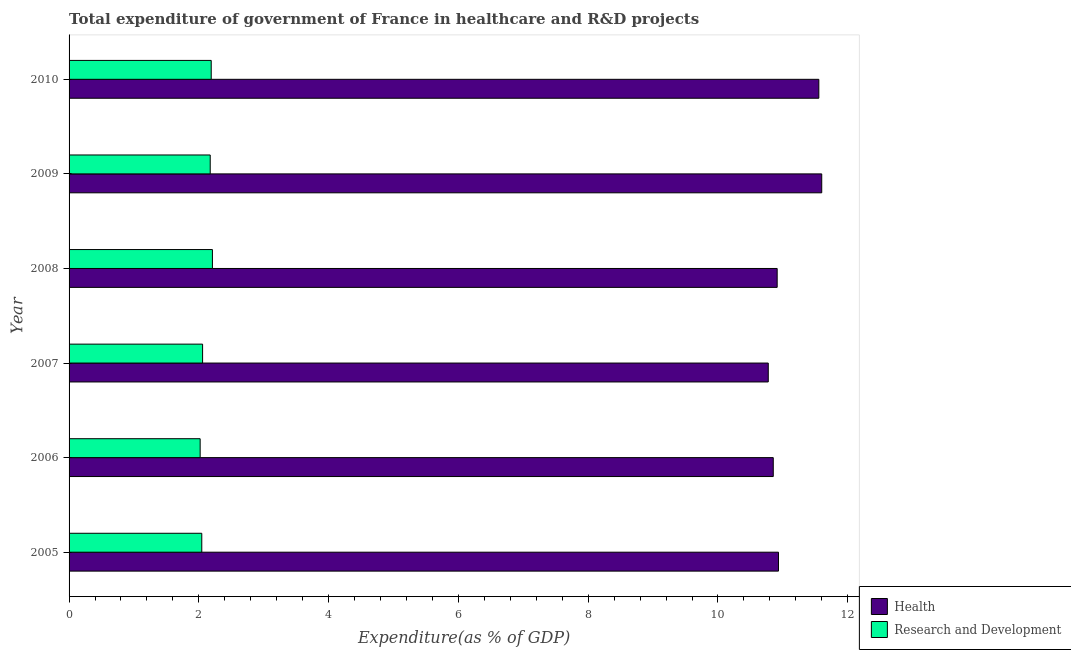How many different coloured bars are there?
Give a very brief answer. 2. What is the label of the 2nd group of bars from the top?
Offer a very short reply. 2009. In how many cases, is the number of bars for a given year not equal to the number of legend labels?
Offer a terse response. 0. What is the expenditure in healthcare in 2005?
Provide a succinct answer. 10.93. Across all years, what is the maximum expenditure in r&d?
Ensure brevity in your answer.  2.21. Across all years, what is the minimum expenditure in r&d?
Offer a terse response. 2.02. What is the total expenditure in healthcare in the graph?
Make the answer very short. 66.63. What is the difference between the expenditure in r&d in 2006 and that in 2009?
Provide a succinct answer. -0.15. What is the difference between the expenditure in healthcare in 2005 and the expenditure in r&d in 2010?
Offer a very short reply. 8.74. What is the average expenditure in healthcare per year?
Keep it short and to the point. 11.1. In the year 2006, what is the difference between the expenditure in r&d and expenditure in healthcare?
Your answer should be compact. -8.83. In how many years, is the expenditure in r&d greater than 4.8 %?
Ensure brevity in your answer.  0. What is the ratio of the expenditure in healthcare in 2005 to that in 2010?
Your answer should be very brief. 0.95. Is the expenditure in healthcare in 2006 less than that in 2007?
Provide a succinct answer. No. What is the difference between the highest and the second highest expenditure in r&d?
Give a very brief answer. 0.02. What is the difference between the highest and the lowest expenditure in healthcare?
Provide a succinct answer. 0.82. Is the sum of the expenditure in healthcare in 2005 and 2009 greater than the maximum expenditure in r&d across all years?
Provide a succinct answer. Yes. What does the 2nd bar from the top in 2006 represents?
Your answer should be very brief. Health. What does the 2nd bar from the bottom in 2010 represents?
Make the answer very short. Research and Development. How many bars are there?
Make the answer very short. 12. What is the difference between two consecutive major ticks on the X-axis?
Offer a very short reply. 2. Are the values on the major ticks of X-axis written in scientific E-notation?
Your answer should be very brief. No. Does the graph contain grids?
Provide a short and direct response. No. Where does the legend appear in the graph?
Provide a succinct answer. Bottom right. How are the legend labels stacked?
Your response must be concise. Vertical. What is the title of the graph?
Offer a terse response. Total expenditure of government of France in healthcare and R&D projects. Does "Arms imports" appear as one of the legend labels in the graph?
Ensure brevity in your answer.  No. What is the label or title of the X-axis?
Your response must be concise. Expenditure(as % of GDP). What is the label or title of the Y-axis?
Give a very brief answer. Year. What is the Expenditure(as % of GDP) in Health in 2005?
Make the answer very short. 10.93. What is the Expenditure(as % of GDP) of Research and Development in 2005?
Provide a short and direct response. 2.05. What is the Expenditure(as % of GDP) in Health in 2006?
Offer a terse response. 10.85. What is the Expenditure(as % of GDP) in Research and Development in 2006?
Make the answer very short. 2.02. What is the Expenditure(as % of GDP) in Health in 2007?
Your answer should be compact. 10.78. What is the Expenditure(as % of GDP) in Research and Development in 2007?
Provide a short and direct response. 2.06. What is the Expenditure(as % of GDP) of Health in 2008?
Provide a succinct answer. 10.91. What is the Expenditure(as % of GDP) in Research and Development in 2008?
Make the answer very short. 2.21. What is the Expenditure(as % of GDP) in Health in 2009?
Ensure brevity in your answer.  11.6. What is the Expenditure(as % of GDP) in Research and Development in 2009?
Keep it short and to the point. 2.18. What is the Expenditure(as % of GDP) of Health in 2010?
Ensure brevity in your answer.  11.55. What is the Expenditure(as % of GDP) in Research and Development in 2010?
Provide a succinct answer. 2.19. Across all years, what is the maximum Expenditure(as % of GDP) of Health?
Offer a very short reply. 11.6. Across all years, what is the maximum Expenditure(as % of GDP) of Research and Development?
Provide a short and direct response. 2.21. Across all years, what is the minimum Expenditure(as % of GDP) in Health?
Keep it short and to the point. 10.78. Across all years, what is the minimum Expenditure(as % of GDP) in Research and Development?
Ensure brevity in your answer.  2.02. What is the total Expenditure(as % of GDP) of Health in the graph?
Offer a terse response. 66.63. What is the total Expenditure(as % of GDP) in Research and Development in the graph?
Make the answer very short. 12.7. What is the difference between the Expenditure(as % of GDP) of Health in 2005 and that in 2006?
Your answer should be very brief. 0.08. What is the difference between the Expenditure(as % of GDP) of Research and Development in 2005 and that in 2006?
Offer a terse response. 0.03. What is the difference between the Expenditure(as % of GDP) of Health in 2005 and that in 2007?
Your answer should be compact. 0.16. What is the difference between the Expenditure(as % of GDP) in Research and Development in 2005 and that in 2007?
Keep it short and to the point. -0.01. What is the difference between the Expenditure(as % of GDP) in Health in 2005 and that in 2008?
Ensure brevity in your answer.  0.02. What is the difference between the Expenditure(as % of GDP) in Research and Development in 2005 and that in 2008?
Make the answer very short. -0.16. What is the difference between the Expenditure(as % of GDP) in Health in 2005 and that in 2009?
Keep it short and to the point. -0.67. What is the difference between the Expenditure(as % of GDP) in Research and Development in 2005 and that in 2009?
Offer a terse response. -0.13. What is the difference between the Expenditure(as % of GDP) of Health in 2005 and that in 2010?
Make the answer very short. -0.62. What is the difference between the Expenditure(as % of GDP) in Research and Development in 2005 and that in 2010?
Offer a terse response. -0.15. What is the difference between the Expenditure(as % of GDP) in Health in 2006 and that in 2007?
Give a very brief answer. 0.08. What is the difference between the Expenditure(as % of GDP) in Research and Development in 2006 and that in 2007?
Provide a succinct answer. -0.04. What is the difference between the Expenditure(as % of GDP) of Health in 2006 and that in 2008?
Give a very brief answer. -0.06. What is the difference between the Expenditure(as % of GDP) of Research and Development in 2006 and that in 2008?
Offer a terse response. -0.19. What is the difference between the Expenditure(as % of GDP) in Health in 2006 and that in 2009?
Your answer should be compact. -0.75. What is the difference between the Expenditure(as % of GDP) of Research and Development in 2006 and that in 2009?
Your answer should be compact. -0.16. What is the difference between the Expenditure(as % of GDP) in Health in 2006 and that in 2010?
Provide a succinct answer. -0.7. What is the difference between the Expenditure(as % of GDP) of Research and Development in 2006 and that in 2010?
Offer a very short reply. -0.17. What is the difference between the Expenditure(as % of GDP) of Health in 2007 and that in 2008?
Provide a succinct answer. -0.14. What is the difference between the Expenditure(as % of GDP) of Research and Development in 2007 and that in 2008?
Offer a terse response. -0.15. What is the difference between the Expenditure(as % of GDP) of Health in 2007 and that in 2009?
Make the answer very short. -0.82. What is the difference between the Expenditure(as % of GDP) of Research and Development in 2007 and that in 2009?
Your answer should be very brief. -0.12. What is the difference between the Expenditure(as % of GDP) of Health in 2007 and that in 2010?
Offer a terse response. -0.78. What is the difference between the Expenditure(as % of GDP) of Research and Development in 2007 and that in 2010?
Provide a succinct answer. -0.13. What is the difference between the Expenditure(as % of GDP) of Health in 2008 and that in 2009?
Your answer should be compact. -0.69. What is the difference between the Expenditure(as % of GDP) in Research and Development in 2008 and that in 2009?
Offer a terse response. 0.03. What is the difference between the Expenditure(as % of GDP) in Health in 2008 and that in 2010?
Ensure brevity in your answer.  -0.64. What is the difference between the Expenditure(as % of GDP) in Research and Development in 2008 and that in 2010?
Your answer should be very brief. 0.02. What is the difference between the Expenditure(as % of GDP) in Health in 2009 and that in 2010?
Provide a succinct answer. 0.04. What is the difference between the Expenditure(as % of GDP) of Research and Development in 2009 and that in 2010?
Keep it short and to the point. -0.02. What is the difference between the Expenditure(as % of GDP) in Health in 2005 and the Expenditure(as % of GDP) in Research and Development in 2006?
Give a very brief answer. 8.91. What is the difference between the Expenditure(as % of GDP) of Health in 2005 and the Expenditure(as % of GDP) of Research and Development in 2007?
Provide a short and direct response. 8.88. What is the difference between the Expenditure(as % of GDP) in Health in 2005 and the Expenditure(as % of GDP) in Research and Development in 2008?
Give a very brief answer. 8.72. What is the difference between the Expenditure(as % of GDP) in Health in 2005 and the Expenditure(as % of GDP) in Research and Development in 2009?
Make the answer very short. 8.76. What is the difference between the Expenditure(as % of GDP) in Health in 2005 and the Expenditure(as % of GDP) in Research and Development in 2010?
Your answer should be very brief. 8.74. What is the difference between the Expenditure(as % of GDP) in Health in 2006 and the Expenditure(as % of GDP) in Research and Development in 2007?
Your response must be concise. 8.79. What is the difference between the Expenditure(as % of GDP) in Health in 2006 and the Expenditure(as % of GDP) in Research and Development in 2008?
Make the answer very short. 8.64. What is the difference between the Expenditure(as % of GDP) in Health in 2006 and the Expenditure(as % of GDP) in Research and Development in 2009?
Offer a very short reply. 8.68. What is the difference between the Expenditure(as % of GDP) in Health in 2006 and the Expenditure(as % of GDP) in Research and Development in 2010?
Your answer should be compact. 8.66. What is the difference between the Expenditure(as % of GDP) of Health in 2007 and the Expenditure(as % of GDP) of Research and Development in 2008?
Offer a terse response. 8.57. What is the difference between the Expenditure(as % of GDP) in Health in 2007 and the Expenditure(as % of GDP) in Research and Development in 2010?
Provide a short and direct response. 8.58. What is the difference between the Expenditure(as % of GDP) in Health in 2008 and the Expenditure(as % of GDP) in Research and Development in 2009?
Keep it short and to the point. 8.74. What is the difference between the Expenditure(as % of GDP) of Health in 2008 and the Expenditure(as % of GDP) of Research and Development in 2010?
Offer a terse response. 8.72. What is the difference between the Expenditure(as % of GDP) in Health in 2009 and the Expenditure(as % of GDP) in Research and Development in 2010?
Ensure brevity in your answer.  9.41. What is the average Expenditure(as % of GDP) of Health per year?
Offer a very short reply. 11.1. What is the average Expenditure(as % of GDP) in Research and Development per year?
Offer a very short reply. 2.12. In the year 2005, what is the difference between the Expenditure(as % of GDP) in Health and Expenditure(as % of GDP) in Research and Development?
Offer a terse response. 8.89. In the year 2006, what is the difference between the Expenditure(as % of GDP) of Health and Expenditure(as % of GDP) of Research and Development?
Your answer should be compact. 8.83. In the year 2007, what is the difference between the Expenditure(as % of GDP) of Health and Expenditure(as % of GDP) of Research and Development?
Your response must be concise. 8.72. In the year 2008, what is the difference between the Expenditure(as % of GDP) of Health and Expenditure(as % of GDP) of Research and Development?
Make the answer very short. 8.7. In the year 2009, what is the difference between the Expenditure(as % of GDP) in Health and Expenditure(as % of GDP) in Research and Development?
Ensure brevity in your answer.  9.42. In the year 2010, what is the difference between the Expenditure(as % of GDP) in Health and Expenditure(as % of GDP) in Research and Development?
Make the answer very short. 9.36. What is the ratio of the Expenditure(as % of GDP) in Health in 2005 to that in 2006?
Offer a very short reply. 1.01. What is the ratio of the Expenditure(as % of GDP) of Research and Development in 2005 to that in 2006?
Your response must be concise. 1.01. What is the ratio of the Expenditure(as % of GDP) of Health in 2005 to that in 2007?
Offer a terse response. 1.01. What is the ratio of the Expenditure(as % of GDP) of Research and Development in 2005 to that in 2008?
Your answer should be very brief. 0.93. What is the ratio of the Expenditure(as % of GDP) in Health in 2005 to that in 2009?
Make the answer very short. 0.94. What is the ratio of the Expenditure(as % of GDP) of Research and Development in 2005 to that in 2009?
Make the answer very short. 0.94. What is the ratio of the Expenditure(as % of GDP) in Health in 2005 to that in 2010?
Keep it short and to the point. 0.95. What is the ratio of the Expenditure(as % of GDP) in Research and Development in 2005 to that in 2010?
Your answer should be compact. 0.93. What is the ratio of the Expenditure(as % of GDP) in Health in 2006 to that in 2007?
Provide a short and direct response. 1.01. What is the ratio of the Expenditure(as % of GDP) of Research and Development in 2006 to that in 2007?
Provide a succinct answer. 0.98. What is the ratio of the Expenditure(as % of GDP) in Health in 2006 to that in 2008?
Provide a succinct answer. 0.99. What is the ratio of the Expenditure(as % of GDP) in Research and Development in 2006 to that in 2008?
Keep it short and to the point. 0.91. What is the ratio of the Expenditure(as % of GDP) of Health in 2006 to that in 2009?
Keep it short and to the point. 0.94. What is the ratio of the Expenditure(as % of GDP) in Research and Development in 2006 to that in 2009?
Make the answer very short. 0.93. What is the ratio of the Expenditure(as % of GDP) of Health in 2006 to that in 2010?
Ensure brevity in your answer.  0.94. What is the ratio of the Expenditure(as % of GDP) in Research and Development in 2006 to that in 2010?
Give a very brief answer. 0.92. What is the ratio of the Expenditure(as % of GDP) in Health in 2007 to that in 2008?
Keep it short and to the point. 0.99. What is the ratio of the Expenditure(as % of GDP) of Research and Development in 2007 to that in 2008?
Offer a terse response. 0.93. What is the ratio of the Expenditure(as % of GDP) in Health in 2007 to that in 2009?
Offer a terse response. 0.93. What is the ratio of the Expenditure(as % of GDP) of Research and Development in 2007 to that in 2009?
Give a very brief answer. 0.95. What is the ratio of the Expenditure(as % of GDP) in Health in 2007 to that in 2010?
Provide a short and direct response. 0.93. What is the ratio of the Expenditure(as % of GDP) in Research and Development in 2007 to that in 2010?
Your response must be concise. 0.94. What is the ratio of the Expenditure(as % of GDP) in Health in 2008 to that in 2009?
Provide a succinct answer. 0.94. What is the ratio of the Expenditure(as % of GDP) of Research and Development in 2008 to that in 2009?
Your answer should be compact. 1.02. What is the ratio of the Expenditure(as % of GDP) of Research and Development in 2008 to that in 2010?
Make the answer very short. 1.01. What is the ratio of the Expenditure(as % of GDP) of Health in 2009 to that in 2010?
Your response must be concise. 1. What is the ratio of the Expenditure(as % of GDP) of Research and Development in 2009 to that in 2010?
Offer a very short reply. 0.99. What is the difference between the highest and the second highest Expenditure(as % of GDP) in Health?
Provide a succinct answer. 0.04. What is the difference between the highest and the second highest Expenditure(as % of GDP) in Research and Development?
Ensure brevity in your answer.  0.02. What is the difference between the highest and the lowest Expenditure(as % of GDP) in Health?
Keep it short and to the point. 0.82. What is the difference between the highest and the lowest Expenditure(as % of GDP) in Research and Development?
Offer a very short reply. 0.19. 